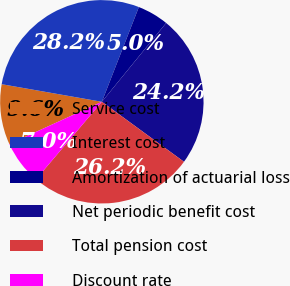Convert chart. <chart><loc_0><loc_0><loc_500><loc_500><pie_chart><fcel>Service cost<fcel>Interest cost<fcel>Amortization of actuarial loss<fcel>Net periodic benefit cost<fcel>Total pension cost<fcel>Discount rate<nl><fcel>9.59%<fcel>28.16%<fcel>4.96%<fcel>24.15%<fcel>26.16%<fcel>6.97%<nl></chart> 